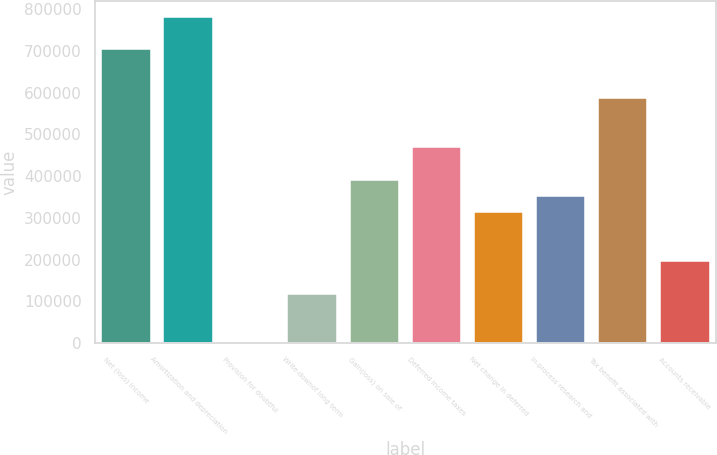<chart> <loc_0><loc_0><loc_500><loc_500><bar_chart><fcel>Net (loss) income<fcel>Amortization and depreciation<fcel>Provision for doubtful<fcel>Write-downof long term<fcel>Gain(loss) on sale of<fcel>Deferred income taxes<fcel>Net change in deferred<fcel>In-process research and<fcel>Tax benefit associated with<fcel>Accounts receivable<nl><fcel>703500<fcel>781491<fcel>1577<fcel>118564<fcel>391534<fcel>469525<fcel>313543<fcel>352538<fcel>586512<fcel>196556<nl></chart> 